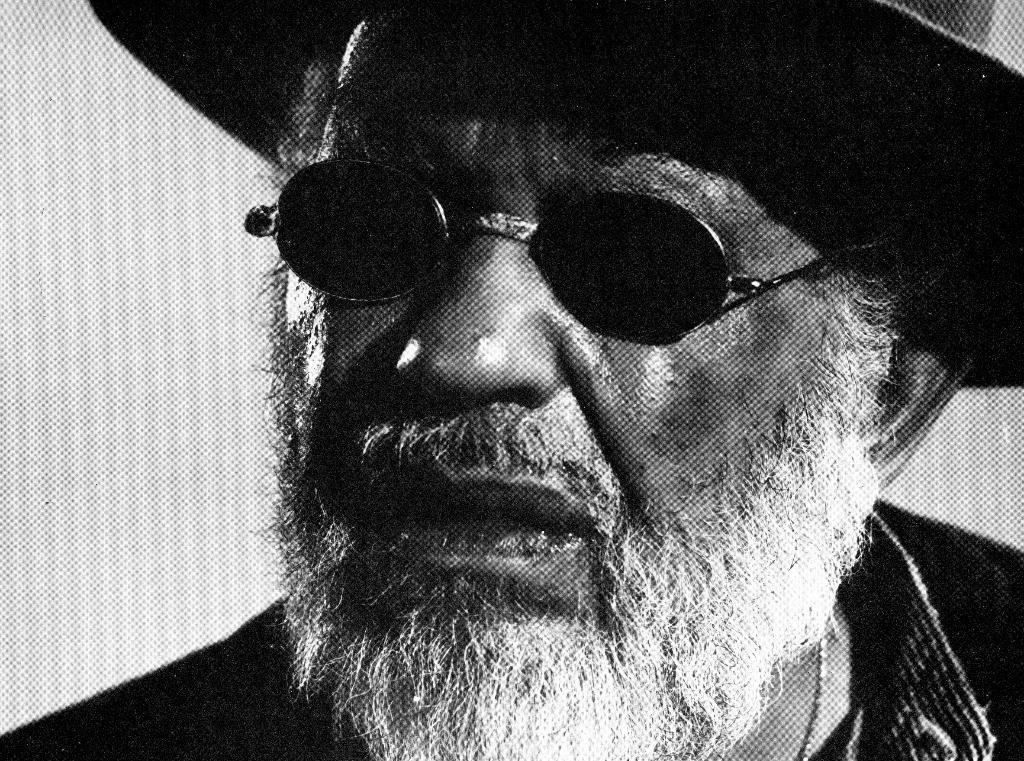Can you describe this image briefly? In the picture we can see a face of the man with a white beard, goggles and hat. 